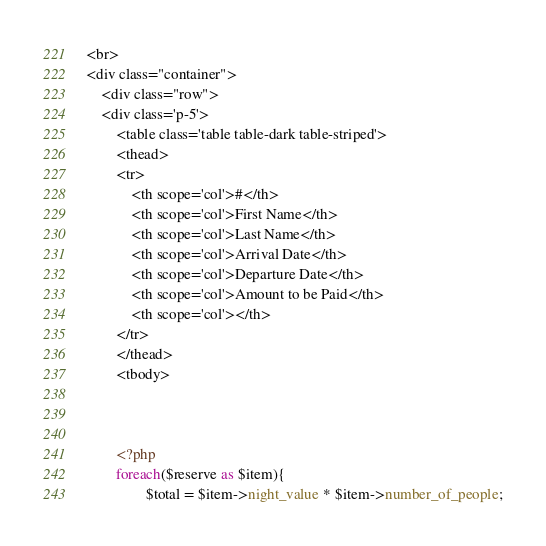<code> <loc_0><loc_0><loc_500><loc_500><_PHP_>

<br>
<div class="container">
    <div class="row">
    <div class='p-5'>
        <table class='table table-dark table-striped'>
        <thead>
        <tr>
            <th scope='col'>#</th>
            <th scope='col'>First Name</th>
            <th scope='col'>Last Name</th>
            <th scope='col'>Arrival Date</th>
            <th scope='col'>Departure Date</th>
            <th scope='col'>Amount to be Paid</th>
            <th scope='col'></th>
        </tr>
        </thead>
        <tbody>
       
 

        <?php 
        foreach($reserve as $item){
                $total = $item->night_value * $item->number_of_people;</code> 